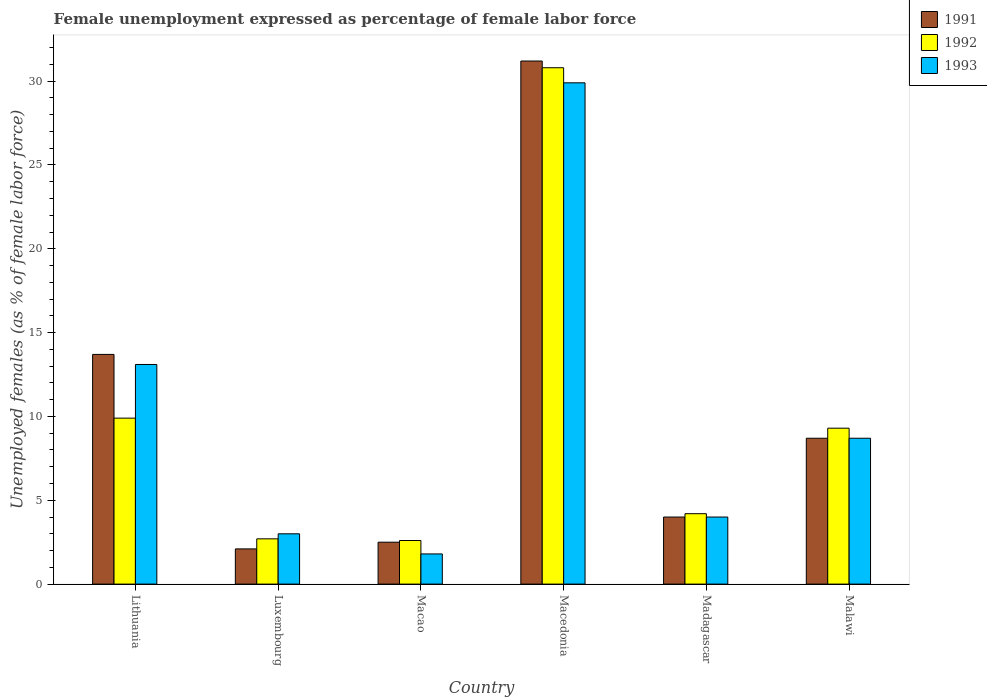How many groups of bars are there?
Give a very brief answer. 6. Are the number of bars per tick equal to the number of legend labels?
Your answer should be compact. Yes. Are the number of bars on each tick of the X-axis equal?
Offer a very short reply. Yes. What is the label of the 2nd group of bars from the left?
Ensure brevity in your answer.  Luxembourg. In how many cases, is the number of bars for a given country not equal to the number of legend labels?
Keep it short and to the point. 0. What is the unemployment in females in in 1992 in Macao?
Ensure brevity in your answer.  2.6. Across all countries, what is the maximum unemployment in females in in 1993?
Your answer should be compact. 29.9. Across all countries, what is the minimum unemployment in females in in 1991?
Offer a terse response. 2.1. In which country was the unemployment in females in in 1991 maximum?
Your response must be concise. Macedonia. In which country was the unemployment in females in in 1992 minimum?
Keep it short and to the point. Macao. What is the total unemployment in females in in 1992 in the graph?
Ensure brevity in your answer.  59.5. What is the difference between the unemployment in females in in 1992 in Macao and that in Madagascar?
Your answer should be very brief. -1.6. What is the difference between the unemployment in females in in 1992 in Madagascar and the unemployment in females in in 1991 in Macedonia?
Your answer should be very brief. -27. What is the average unemployment in females in in 1991 per country?
Offer a terse response. 10.37. What is the difference between the unemployment in females in of/in 1992 and unemployment in females in of/in 1993 in Luxembourg?
Your answer should be compact. -0.3. What is the ratio of the unemployment in females in in 1991 in Lithuania to that in Macedonia?
Give a very brief answer. 0.44. Is the unemployment in females in in 1992 in Luxembourg less than that in Madagascar?
Your answer should be compact. Yes. Is the difference between the unemployment in females in in 1992 in Macedonia and Malawi greater than the difference between the unemployment in females in in 1993 in Macedonia and Malawi?
Provide a succinct answer. Yes. What is the difference between the highest and the second highest unemployment in females in in 1992?
Give a very brief answer. -20.9. What is the difference between the highest and the lowest unemployment in females in in 1992?
Give a very brief answer. 28.2. Is the sum of the unemployment in females in in 1993 in Madagascar and Malawi greater than the maximum unemployment in females in in 1992 across all countries?
Ensure brevity in your answer.  No. What does the 1st bar from the right in Madagascar represents?
Provide a succinct answer. 1993. Is it the case that in every country, the sum of the unemployment in females in in 1991 and unemployment in females in in 1993 is greater than the unemployment in females in in 1992?
Give a very brief answer. Yes. Are all the bars in the graph horizontal?
Your response must be concise. No. How many countries are there in the graph?
Offer a very short reply. 6. What is the difference between two consecutive major ticks on the Y-axis?
Your answer should be very brief. 5. What is the title of the graph?
Give a very brief answer. Female unemployment expressed as percentage of female labor force. What is the label or title of the X-axis?
Provide a short and direct response. Country. What is the label or title of the Y-axis?
Offer a very short reply. Unemployed females (as % of female labor force). What is the Unemployed females (as % of female labor force) in 1991 in Lithuania?
Make the answer very short. 13.7. What is the Unemployed females (as % of female labor force) of 1992 in Lithuania?
Give a very brief answer. 9.9. What is the Unemployed females (as % of female labor force) of 1993 in Lithuania?
Your answer should be compact. 13.1. What is the Unemployed females (as % of female labor force) in 1991 in Luxembourg?
Offer a very short reply. 2.1. What is the Unemployed females (as % of female labor force) in 1992 in Luxembourg?
Provide a succinct answer. 2.7. What is the Unemployed females (as % of female labor force) in 1993 in Luxembourg?
Keep it short and to the point. 3. What is the Unemployed females (as % of female labor force) in 1992 in Macao?
Your response must be concise. 2.6. What is the Unemployed females (as % of female labor force) in 1993 in Macao?
Keep it short and to the point. 1.8. What is the Unemployed females (as % of female labor force) of 1991 in Macedonia?
Give a very brief answer. 31.2. What is the Unemployed females (as % of female labor force) of 1992 in Macedonia?
Ensure brevity in your answer.  30.8. What is the Unemployed females (as % of female labor force) in 1993 in Macedonia?
Make the answer very short. 29.9. What is the Unemployed females (as % of female labor force) of 1992 in Madagascar?
Provide a succinct answer. 4.2. What is the Unemployed females (as % of female labor force) of 1991 in Malawi?
Offer a very short reply. 8.7. What is the Unemployed females (as % of female labor force) of 1992 in Malawi?
Provide a succinct answer. 9.3. What is the Unemployed females (as % of female labor force) of 1993 in Malawi?
Offer a terse response. 8.7. Across all countries, what is the maximum Unemployed females (as % of female labor force) in 1991?
Your answer should be very brief. 31.2. Across all countries, what is the maximum Unemployed females (as % of female labor force) of 1992?
Give a very brief answer. 30.8. Across all countries, what is the maximum Unemployed females (as % of female labor force) in 1993?
Your answer should be compact. 29.9. Across all countries, what is the minimum Unemployed females (as % of female labor force) of 1991?
Make the answer very short. 2.1. Across all countries, what is the minimum Unemployed females (as % of female labor force) of 1992?
Make the answer very short. 2.6. Across all countries, what is the minimum Unemployed females (as % of female labor force) of 1993?
Offer a very short reply. 1.8. What is the total Unemployed females (as % of female labor force) in 1991 in the graph?
Your response must be concise. 62.2. What is the total Unemployed females (as % of female labor force) of 1992 in the graph?
Ensure brevity in your answer.  59.5. What is the total Unemployed females (as % of female labor force) of 1993 in the graph?
Make the answer very short. 60.5. What is the difference between the Unemployed females (as % of female labor force) of 1991 in Lithuania and that in Luxembourg?
Your response must be concise. 11.6. What is the difference between the Unemployed females (as % of female labor force) of 1992 in Lithuania and that in Luxembourg?
Ensure brevity in your answer.  7.2. What is the difference between the Unemployed females (as % of female labor force) in 1993 in Lithuania and that in Luxembourg?
Keep it short and to the point. 10.1. What is the difference between the Unemployed females (as % of female labor force) in 1991 in Lithuania and that in Macao?
Offer a very short reply. 11.2. What is the difference between the Unemployed females (as % of female labor force) of 1992 in Lithuania and that in Macao?
Your response must be concise. 7.3. What is the difference between the Unemployed females (as % of female labor force) in 1991 in Lithuania and that in Macedonia?
Your answer should be compact. -17.5. What is the difference between the Unemployed females (as % of female labor force) in 1992 in Lithuania and that in Macedonia?
Provide a succinct answer. -20.9. What is the difference between the Unemployed females (as % of female labor force) of 1993 in Lithuania and that in Macedonia?
Your answer should be compact. -16.8. What is the difference between the Unemployed females (as % of female labor force) of 1991 in Lithuania and that in Madagascar?
Your answer should be compact. 9.7. What is the difference between the Unemployed females (as % of female labor force) of 1992 in Lithuania and that in Madagascar?
Offer a very short reply. 5.7. What is the difference between the Unemployed females (as % of female labor force) in 1991 in Lithuania and that in Malawi?
Keep it short and to the point. 5. What is the difference between the Unemployed females (as % of female labor force) of 1993 in Lithuania and that in Malawi?
Make the answer very short. 4.4. What is the difference between the Unemployed females (as % of female labor force) in 1991 in Luxembourg and that in Macao?
Offer a very short reply. -0.4. What is the difference between the Unemployed females (as % of female labor force) of 1993 in Luxembourg and that in Macao?
Provide a succinct answer. 1.2. What is the difference between the Unemployed females (as % of female labor force) in 1991 in Luxembourg and that in Macedonia?
Make the answer very short. -29.1. What is the difference between the Unemployed females (as % of female labor force) in 1992 in Luxembourg and that in Macedonia?
Keep it short and to the point. -28.1. What is the difference between the Unemployed females (as % of female labor force) in 1993 in Luxembourg and that in Macedonia?
Ensure brevity in your answer.  -26.9. What is the difference between the Unemployed females (as % of female labor force) in 1992 in Luxembourg and that in Madagascar?
Provide a succinct answer. -1.5. What is the difference between the Unemployed females (as % of female labor force) in 1991 in Luxembourg and that in Malawi?
Make the answer very short. -6.6. What is the difference between the Unemployed females (as % of female labor force) of 1991 in Macao and that in Macedonia?
Your response must be concise. -28.7. What is the difference between the Unemployed females (as % of female labor force) in 1992 in Macao and that in Macedonia?
Your answer should be very brief. -28.2. What is the difference between the Unemployed females (as % of female labor force) of 1993 in Macao and that in Macedonia?
Ensure brevity in your answer.  -28.1. What is the difference between the Unemployed females (as % of female labor force) in 1992 in Macao and that in Madagascar?
Keep it short and to the point. -1.6. What is the difference between the Unemployed females (as % of female labor force) in 1992 in Macao and that in Malawi?
Your answer should be compact. -6.7. What is the difference between the Unemployed females (as % of female labor force) of 1991 in Macedonia and that in Madagascar?
Your answer should be compact. 27.2. What is the difference between the Unemployed females (as % of female labor force) in 1992 in Macedonia and that in Madagascar?
Provide a succinct answer. 26.6. What is the difference between the Unemployed females (as % of female labor force) in 1993 in Macedonia and that in Madagascar?
Offer a very short reply. 25.9. What is the difference between the Unemployed females (as % of female labor force) in 1991 in Macedonia and that in Malawi?
Offer a very short reply. 22.5. What is the difference between the Unemployed females (as % of female labor force) in 1993 in Macedonia and that in Malawi?
Offer a very short reply. 21.2. What is the difference between the Unemployed females (as % of female labor force) in 1991 in Madagascar and that in Malawi?
Keep it short and to the point. -4.7. What is the difference between the Unemployed females (as % of female labor force) of 1992 in Madagascar and that in Malawi?
Provide a succinct answer. -5.1. What is the difference between the Unemployed females (as % of female labor force) in 1991 in Lithuania and the Unemployed females (as % of female labor force) in 1993 in Luxembourg?
Keep it short and to the point. 10.7. What is the difference between the Unemployed females (as % of female labor force) of 1992 in Lithuania and the Unemployed females (as % of female labor force) of 1993 in Luxembourg?
Provide a short and direct response. 6.9. What is the difference between the Unemployed females (as % of female labor force) in 1991 in Lithuania and the Unemployed females (as % of female labor force) in 1992 in Macao?
Give a very brief answer. 11.1. What is the difference between the Unemployed females (as % of female labor force) in 1991 in Lithuania and the Unemployed females (as % of female labor force) in 1993 in Macao?
Your answer should be compact. 11.9. What is the difference between the Unemployed females (as % of female labor force) in 1992 in Lithuania and the Unemployed females (as % of female labor force) in 1993 in Macao?
Make the answer very short. 8.1. What is the difference between the Unemployed females (as % of female labor force) in 1991 in Lithuania and the Unemployed females (as % of female labor force) in 1992 in Macedonia?
Provide a succinct answer. -17.1. What is the difference between the Unemployed females (as % of female labor force) in 1991 in Lithuania and the Unemployed females (as % of female labor force) in 1993 in Macedonia?
Your answer should be very brief. -16.2. What is the difference between the Unemployed females (as % of female labor force) of 1991 in Lithuania and the Unemployed females (as % of female labor force) of 1992 in Madagascar?
Ensure brevity in your answer.  9.5. What is the difference between the Unemployed females (as % of female labor force) of 1991 in Lithuania and the Unemployed females (as % of female labor force) of 1993 in Madagascar?
Provide a short and direct response. 9.7. What is the difference between the Unemployed females (as % of female labor force) of 1992 in Lithuania and the Unemployed females (as % of female labor force) of 1993 in Madagascar?
Your answer should be very brief. 5.9. What is the difference between the Unemployed females (as % of female labor force) of 1991 in Lithuania and the Unemployed females (as % of female labor force) of 1992 in Malawi?
Keep it short and to the point. 4.4. What is the difference between the Unemployed females (as % of female labor force) of 1992 in Lithuania and the Unemployed females (as % of female labor force) of 1993 in Malawi?
Offer a very short reply. 1.2. What is the difference between the Unemployed females (as % of female labor force) in 1991 in Luxembourg and the Unemployed females (as % of female labor force) in 1992 in Macao?
Keep it short and to the point. -0.5. What is the difference between the Unemployed females (as % of female labor force) in 1992 in Luxembourg and the Unemployed females (as % of female labor force) in 1993 in Macao?
Offer a terse response. 0.9. What is the difference between the Unemployed females (as % of female labor force) of 1991 in Luxembourg and the Unemployed females (as % of female labor force) of 1992 in Macedonia?
Keep it short and to the point. -28.7. What is the difference between the Unemployed females (as % of female labor force) in 1991 in Luxembourg and the Unemployed females (as % of female labor force) in 1993 in Macedonia?
Offer a terse response. -27.8. What is the difference between the Unemployed females (as % of female labor force) of 1992 in Luxembourg and the Unemployed females (as % of female labor force) of 1993 in Macedonia?
Your answer should be compact. -27.2. What is the difference between the Unemployed females (as % of female labor force) in 1991 in Luxembourg and the Unemployed females (as % of female labor force) in 1992 in Madagascar?
Make the answer very short. -2.1. What is the difference between the Unemployed females (as % of female labor force) in 1991 in Luxembourg and the Unemployed females (as % of female labor force) in 1993 in Malawi?
Keep it short and to the point. -6.6. What is the difference between the Unemployed females (as % of female labor force) in 1991 in Macao and the Unemployed females (as % of female labor force) in 1992 in Macedonia?
Provide a succinct answer. -28.3. What is the difference between the Unemployed females (as % of female labor force) of 1991 in Macao and the Unemployed females (as % of female labor force) of 1993 in Macedonia?
Give a very brief answer. -27.4. What is the difference between the Unemployed females (as % of female labor force) of 1992 in Macao and the Unemployed females (as % of female labor force) of 1993 in Macedonia?
Your response must be concise. -27.3. What is the difference between the Unemployed females (as % of female labor force) of 1991 in Macao and the Unemployed females (as % of female labor force) of 1992 in Madagascar?
Make the answer very short. -1.7. What is the difference between the Unemployed females (as % of female labor force) in 1991 in Macao and the Unemployed females (as % of female labor force) in 1993 in Madagascar?
Provide a succinct answer. -1.5. What is the difference between the Unemployed females (as % of female labor force) of 1992 in Macao and the Unemployed females (as % of female labor force) of 1993 in Madagascar?
Your answer should be very brief. -1.4. What is the difference between the Unemployed females (as % of female labor force) of 1991 in Macao and the Unemployed females (as % of female labor force) of 1992 in Malawi?
Provide a short and direct response. -6.8. What is the difference between the Unemployed females (as % of female labor force) in 1991 in Macao and the Unemployed females (as % of female labor force) in 1993 in Malawi?
Your answer should be very brief. -6.2. What is the difference between the Unemployed females (as % of female labor force) of 1991 in Macedonia and the Unemployed females (as % of female labor force) of 1993 in Madagascar?
Offer a very short reply. 27.2. What is the difference between the Unemployed females (as % of female labor force) of 1992 in Macedonia and the Unemployed females (as % of female labor force) of 1993 in Madagascar?
Provide a short and direct response. 26.8. What is the difference between the Unemployed females (as % of female labor force) of 1991 in Macedonia and the Unemployed females (as % of female labor force) of 1992 in Malawi?
Your answer should be compact. 21.9. What is the difference between the Unemployed females (as % of female labor force) of 1991 in Macedonia and the Unemployed females (as % of female labor force) of 1993 in Malawi?
Ensure brevity in your answer.  22.5. What is the difference between the Unemployed females (as % of female labor force) of 1992 in Macedonia and the Unemployed females (as % of female labor force) of 1993 in Malawi?
Provide a short and direct response. 22.1. What is the difference between the Unemployed females (as % of female labor force) in 1991 in Madagascar and the Unemployed females (as % of female labor force) in 1992 in Malawi?
Provide a short and direct response. -5.3. What is the average Unemployed females (as % of female labor force) in 1991 per country?
Your answer should be very brief. 10.37. What is the average Unemployed females (as % of female labor force) in 1992 per country?
Give a very brief answer. 9.92. What is the average Unemployed females (as % of female labor force) in 1993 per country?
Ensure brevity in your answer.  10.08. What is the difference between the Unemployed females (as % of female labor force) in 1991 and Unemployed females (as % of female labor force) in 1992 in Luxembourg?
Your answer should be compact. -0.6. What is the difference between the Unemployed females (as % of female labor force) in 1991 and Unemployed females (as % of female labor force) in 1993 in Luxembourg?
Offer a very short reply. -0.9. What is the difference between the Unemployed females (as % of female labor force) in 1991 and Unemployed females (as % of female labor force) in 1992 in Macedonia?
Your answer should be very brief. 0.4. What is the difference between the Unemployed females (as % of female labor force) of 1992 and Unemployed females (as % of female labor force) of 1993 in Macedonia?
Provide a short and direct response. 0.9. What is the difference between the Unemployed females (as % of female labor force) in 1991 and Unemployed females (as % of female labor force) in 1993 in Madagascar?
Ensure brevity in your answer.  0. What is the difference between the Unemployed females (as % of female labor force) in 1991 and Unemployed females (as % of female labor force) in 1992 in Malawi?
Offer a very short reply. -0.6. What is the difference between the Unemployed females (as % of female labor force) of 1992 and Unemployed females (as % of female labor force) of 1993 in Malawi?
Provide a short and direct response. 0.6. What is the ratio of the Unemployed females (as % of female labor force) in 1991 in Lithuania to that in Luxembourg?
Provide a short and direct response. 6.52. What is the ratio of the Unemployed females (as % of female labor force) of 1992 in Lithuania to that in Luxembourg?
Ensure brevity in your answer.  3.67. What is the ratio of the Unemployed females (as % of female labor force) of 1993 in Lithuania to that in Luxembourg?
Provide a succinct answer. 4.37. What is the ratio of the Unemployed females (as % of female labor force) in 1991 in Lithuania to that in Macao?
Keep it short and to the point. 5.48. What is the ratio of the Unemployed females (as % of female labor force) in 1992 in Lithuania to that in Macao?
Make the answer very short. 3.81. What is the ratio of the Unemployed females (as % of female labor force) of 1993 in Lithuania to that in Macao?
Give a very brief answer. 7.28. What is the ratio of the Unemployed females (as % of female labor force) in 1991 in Lithuania to that in Macedonia?
Your response must be concise. 0.44. What is the ratio of the Unemployed females (as % of female labor force) in 1992 in Lithuania to that in Macedonia?
Offer a very short reply. 0.32. What is the ratio of the Unemployed females (as % of female labor force) of 1993 in Lithuania to that in Macedonia?
Give a very brief answer. 0.44. What is the ratio of the Unemployed females (as % of female labor force) of 1991 in Lithuania to that in Madagascar?
Give a very brief answer. 3.42. What is the ratio of the Unemployed females (as % of female labor force) of 1992 in Lithuania to that in Madagascar?
Offer a terse response. 2.36. What is the ratio of the Unemployed females (as % of female labor force) of 1993 in Lithuania to that in Madagascar?
Give a very brief answer. 3.27. What is the ratio of the Unemployed females (as % of female labor force) in 1991 in Lithuania to that in Malawi?
Make the answer very short. 1.57. What is the ratio of the Unemployed females (as % of female labor force) of 1992 in Lithuania to that in Malawi?
Your response must be concise. 1.06. What is the ratio of the Unemployed females (as % of female labor force) of 1993 in Lithuania to that in Malawi?
Keep it short and to the point. 1.51. What is the ratio of the Unemployed females (as % of female labor force) in 1991 in Luxembourg to that in Macao?
Ensure brevity in your answer.  0.84. What is the ratio of the Unemployed females (as % of female labor force) of 1992 in Luxembourg to that in Macao?
Keep it short and to the point. 1.04. What is the ratio of the Unemployed females (as % of female labor force) in 1993 in Luxembourg to that in Macao?
Your answer should be very brief. 1.67. What is the ratio of the Unemployed females (as % of female labor force) of 1991 in Luxembourg to that in Macedonia?
Provide a short and direct response. 0.07. What is the ratio of the Unemployed females (as % of female labor force) of 1992 in Luxembourg to that in Macedonia?
Keep it short and to the point. 0.09. What is the ratio of the Unemployed females (as % of female labor force) of 1993 in Luxembourg to that in Macedonia?
Give a very brief answer. 0.1. What is the ratio of the Unemployed females (as % of female labor force) in 1991 in Luxembourg to that in Madagascar?
Make the answer very short. 0.53. What is the ratio of the Unemployed females (as % of female labor force) in 1992 in Luxembourg to that in Madagascar?
Your answer should be compact. 0.64. What is the ratio of the Unemployed females (as % of female labor force) in 1991 in Luxembourg to that in Malawi?
Provide a short and direct response. 0.24. What is the ratio of the Unemployed females (as % of female labor force) in 1992 in Luxembourg to that in Malawi?
Offer a very short reply. 0.29. What is the ratio of the Unemployed females (as % of female labor force) in 1993 in Luxembourg to that in Malawi?
Your answer should be very brief. 0.34. What is the ratio of the Unemployed females (as % of female labor force) in 1991 in Macao to that in Macedonia?
Your answer should be compact. 0.08. What is the ratio of the Unemployed females (as % of female labor force) of 1992 in Macao to that in Macedonia?
Provide a short and direct response. 0.08. What is the ratio of the Unemployed females (as % of female labor force) of 1993 in Macao to that in Macedonia?
Provide a short and direct response. 0.06. What is the ratio of the Unemployed females (as % of female labor force) in 1992 in Macao to that in Madagascar?
Offer a very short reply. 0.62. What is the ratio of the Unemployed females (as % of female labor force) in 1993 in Macao to that in Madagascar?
Provide a succinct answer. 0.45. What is the ratio of the Unemployed females (as % of female labor force) of 1991 in Macao to that in Malawi?
Ensure brevity in your answer.  0.29. What is the ratio of the Unemployed females (as % of female labor force) of 1992 in Macao to that in Malawi?
Offer a terse response. 0.28. What is the ratio of the Unemployed females (as % of female labor force) of 1993 in Macao to that in Malawi?
Ensure brevity in your answer.  0.21. What is the ratio of the Unemployed females (as % of female labor force) of 1991 in Macedonia to that in Madagascar?
Ensure brevity in your answer.  7.8. What is the ratio of the Unemployed females (as % of female labor force) of 1992 in Macedonia to that in Madagascar?
Ensure brevity in your answer.  7.33. What is the ratio of the Unemployed females (as % of female labor force) in 1993 in Macedonia to that in Madagascar?
Ensure brevity in your answer.  7.47. What is the ratio of the Unemployed females (as % of female labor force) in 1991 in Macedonia to that in Malawi?
Keep it short and to the point. 3.59. What is the ratio of the Unemployed females (as % of female labor force) in 1992 in Macedonia to that in Malawi?
Provide a succinct answer. 3.31. What is the ratio of the Unemployed females (as % of female labor force) of 1993 in Macedonia to that in Malawi?
Ensure brevity in your answer.  3.44. What is the ratio of the Unemployed females (as % of female labor force) in 1991 in Madagascar to that in Malawi?
Your answer should be compact. 0.46. What is the ratio of the Unemployed females (as % of female labor force) of 1992 in Madagascar to that in Malawi?
Provide a succinct answer. 0.45. What is the ratio of the Unemployed females (as % of female labor force) in 1993 in Madagascar to that in Malawi?
Your response must be concise. 0.46. What is the difference between the highest and the second highest Unemployed females (as % of female labor force) in 1991?
Your answer should be very brief. 17.5. What is the difference between the highest and the second highest Unemployed females (as % of female labor force) in 1992?
Offer a terse response. 20.9. What is the difference between the highest and the second highest Unemployed females (as % of female labor force) of 1993?
Your response must be concise. 16.8. What is the difference between the highest and the lowest Unemployed females (as % of female labor force) in 1991?
Your response must be concise. 29.1. What is the difference between the highest and the lowest Unemployed females (as % of female labor force) in 1992?
Provide a short and direct response. 28.2. What is the difference between the highest and the lowest Unemployed females (as % of female labor force) in 1993?
Your answer should be very brief. 28.1. 